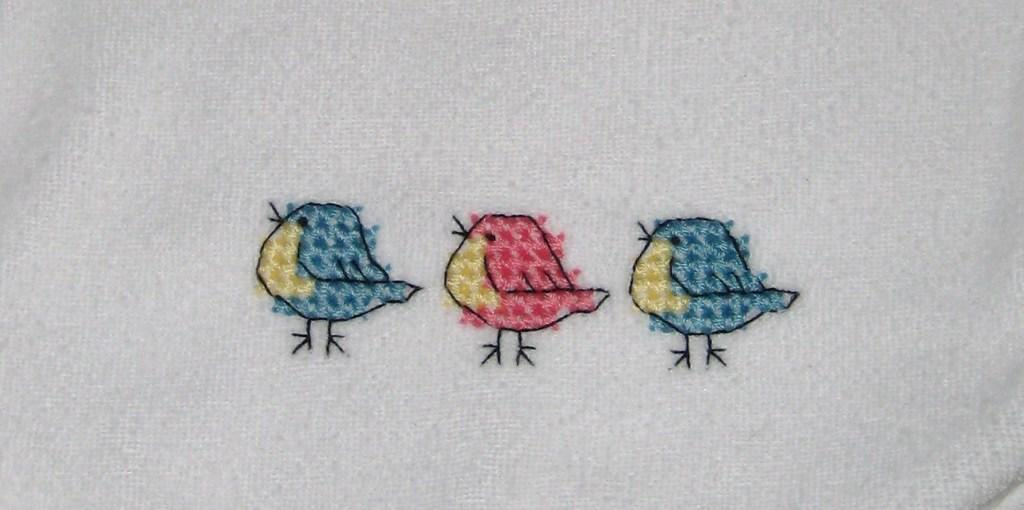What is depicted in the image? There is a drawing of three birds in the image. Can you describe the birds in the drawing? Unfortunately, the facts provided do not include any details about the appearance of the birds. Are there any other elements in the image besides the birds? The facts provided do not mention any other elements in the image. How deep is the drain in the image? There is no drain present in the image; it only contains a drawing of three birds. 